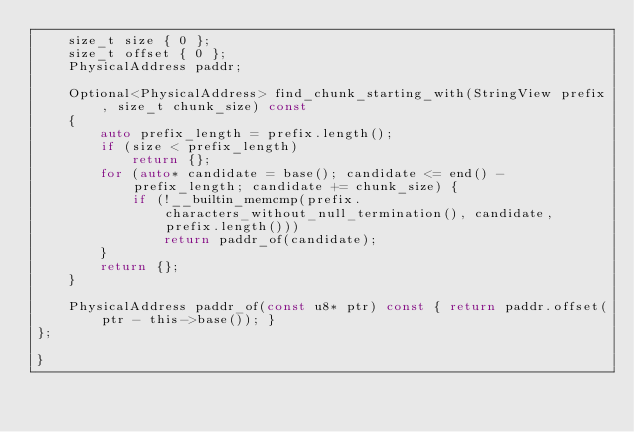<code> <loc_0><loc_0><loc_500><loc_500><_C_>    size_t size { 0 };
    size_t offset { 0 };
    PhysicalAddress paddr;

    Optional<PhysicalAddress> find_chunk_starting_with(StringView prefix, size_t chunk_size) const
    {
        auto prefix_length = prefix.length();
        if (size < prefix_length)
            return {};
        for (auto* candidate = base(); candidate <= end() - prefix_length; candidate += chunk_size) {
            if (!__builtin_memcmp(prefix.characters_without_null_termination(), candidate, prefix.length()))
                return paddr_of(candidate);
        }
        return {};
    }

    PhysicalAddress paddr_of(const u8* ptr) const { return paddr.offset(ptr - this->base()); }
};

}
</code> 